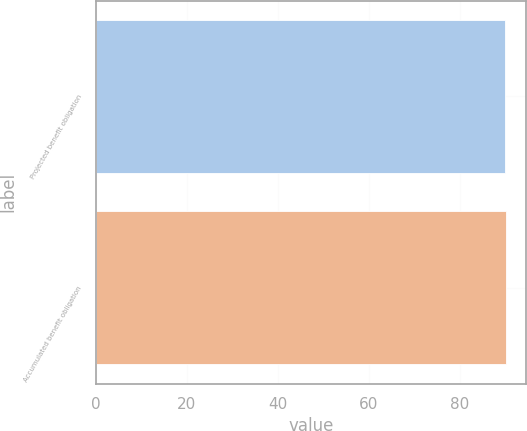<chart> <loc_0><loc_0><loc_500><loc_500><bar_chart><fcel>Projected benefit obligation<fcel>Accumulated benefit obligation<nl><fcel>90<fcel>90.1<nl></chart> 